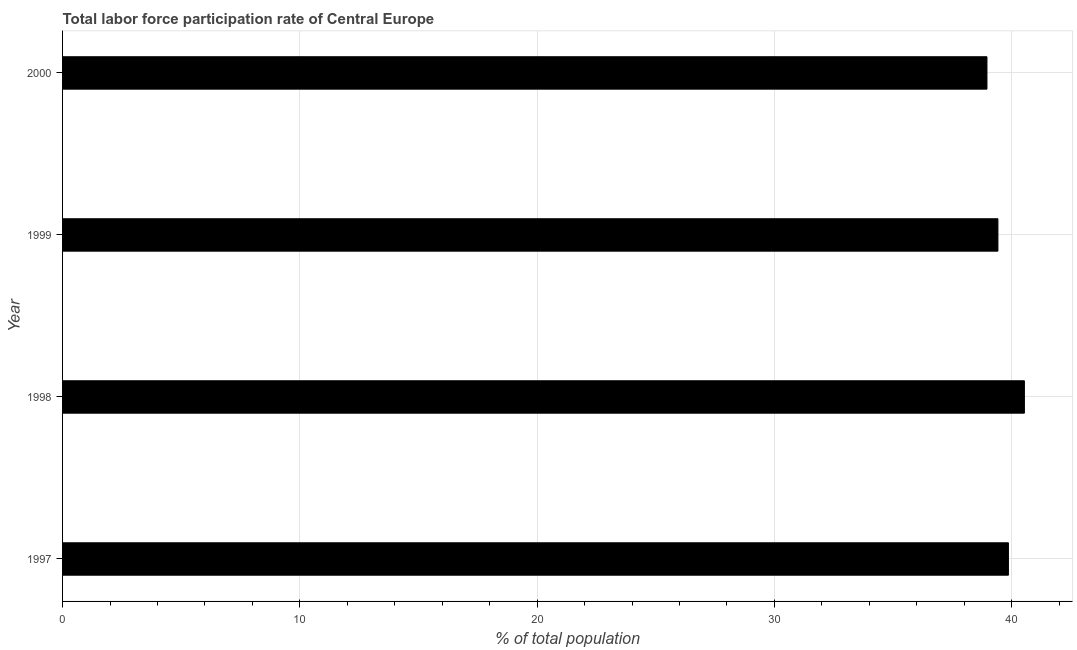What is the title of the graph?
Provide a short and direct response. Total labor force participation rate of Central Europe. What is the label or title of the X-axis?
Give a very brief answer. % of total population. What is the label or title of the Y-axis?
Your answer should be compact. Year. What is the total labor force participation rate in 1999?
Provide a succinct answer. 39.42. Across all years, what is the maximum total labor force participation rate?
Provide a succinct answer. 40.53. Across all years, what is the minimum total labor force participation rate?
Your answer should be very brief. 38.96. In which year was the total labor force participation rate maximum?
Offer a terse response. 1998. In which year was the total labor force participation rate minimum?
Keep it short and to the point. 2000. What is the sum of the total labor force participation rate?
Provide a short and direct response. 158.77. What is the difference between the total labor force participation rate in 1999 and 2000?
Your answer should be very brief. 0.46. What is the average total labor force participation rate per year?
Make the answer very short. 39.69. What is the median total labor force participation rate?
Your answer should be compact. 39.64. What is the difference between the highest and the second highest total labor force participation rate?
Your answer should be compact. 0.67. Is the sum of the total labor force participation rate in 1999 and 2000 greater than the maximum total labor force participation rate across all years?
Provide a succinct answer. Yes. What is the difference between the highest and the lowest total labor force participation rate?
Ensure brevity in your answer.  1.58. How many bars are there?
Keep it short and to the point. 4. Are all the bars in the graph horizontal?
Your answer should be very brief. Yes. How many years are there in the graph?
Your answer should be compact. 4. What is the difference between two consecutive major ticks on the X-axis?
Provide a short and direct response. 10. Are the values on the major ticks of X-axis written in scientific E-notation?
Make the answer very short. No. What is the % of total population of 1997?
Provide a succinct answer. 39.86. What is the % of total population in 1998?
Offer a very short reply. 40.53. What is the % of total population in 1999?
Give a very brief answer. 39.42. What is the % of total population in 2000?
Provide a succinct answer. 38.96. What is the difference between the % of total population in 1997 and 1998?
Your response must be concise. -0.67. What is the difference between the % of total population in 1997 and 1999?
Your response must be concise. 0.44. What is the difference between the % of total population in 1997 and 2000?
Your response must be concise. 0.9. What is the difference between the % of total population in 1998 and 1999?
Give a very brief answer. 1.12. What is the difference between the % of total population in 1998 and 2000?
Ensure brevity in your answer.  1.58. What is the difference between the % of total population in 1999 and 2000?
Provide a succinct answer. 0.46. What is the ratio of the % of total population in 1997 to that in 1998?
Provide a succinct answer. 0.98. What is the ratio of the % of total population in 1998 to that in 1999?
Ensure brevity in your answer.  1.03. What is the ratio of the % of total population in 1998 to that in 2000?
Provide a succinct answer. 1.04. What is the ratio of the % of total population in 1999 to that in 2000?
Make the answer very short. 1.01. 